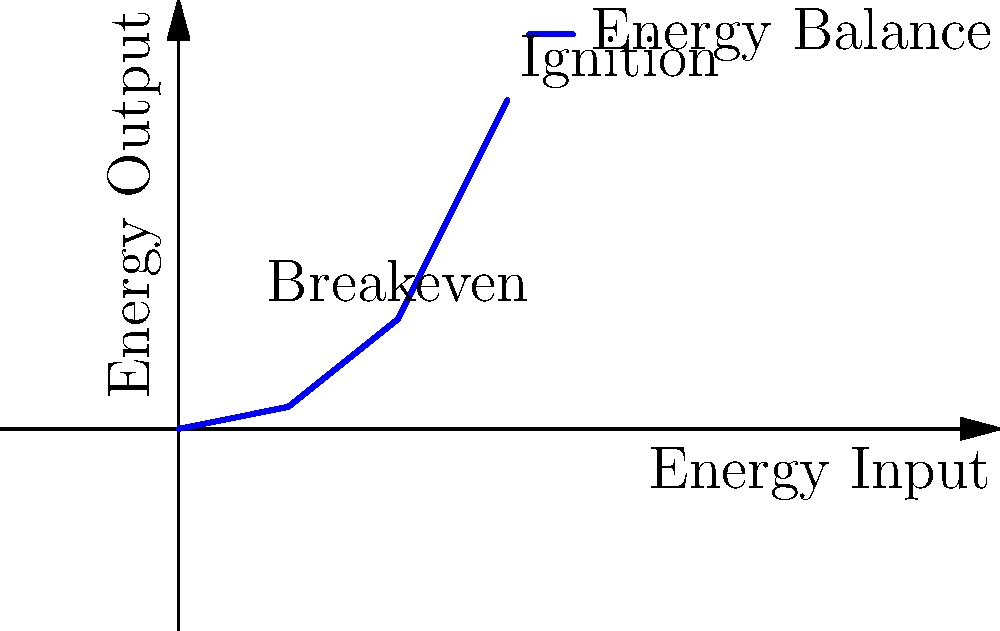In the graphical representation of energy balance for inertial confinement fusion, what does the point where the curve intersects the line $y = x$ represent, and why is this point significant in fusion research? To answer this question, let's analyze the graph step-by-step:

1. The x-axis represents energy input, while the y-axis represents energy output in the fusion process.

2. The blue curve shows the relationship between input and output energies.

3. The point where this curve intersects the line $y = x$ (which would be a 45-degree line from the origin, though not explicitly drawn) is called the breakeven point.

4. At this point, the energy output equals the energy input. Mathematically, this is where $E_{out} = E_{in}$.

5. This point is significant because:
   a) It represents the minimum condition for fusion to be energetically viable.
   b) Below this point, more energy is put into the system than is produced (fusion is a net energy consumer).
   c) Above this point, the fusion process produces more energy than it consumes (net energy producer).

6. In practical fusion research, the goal is to achieve conditions well above the breakeven point, ideally reaching ignition where the fusion reaction becomes self-sustaining.

7. On the graph, we can see that after the breakeven point, the curve rises more steeply, indicating that small increases in input energy can lead to much larger increases in output energy.
Answer: Breakeven point: where energy output equals energy input ($E_{out} = E_{in}$) 